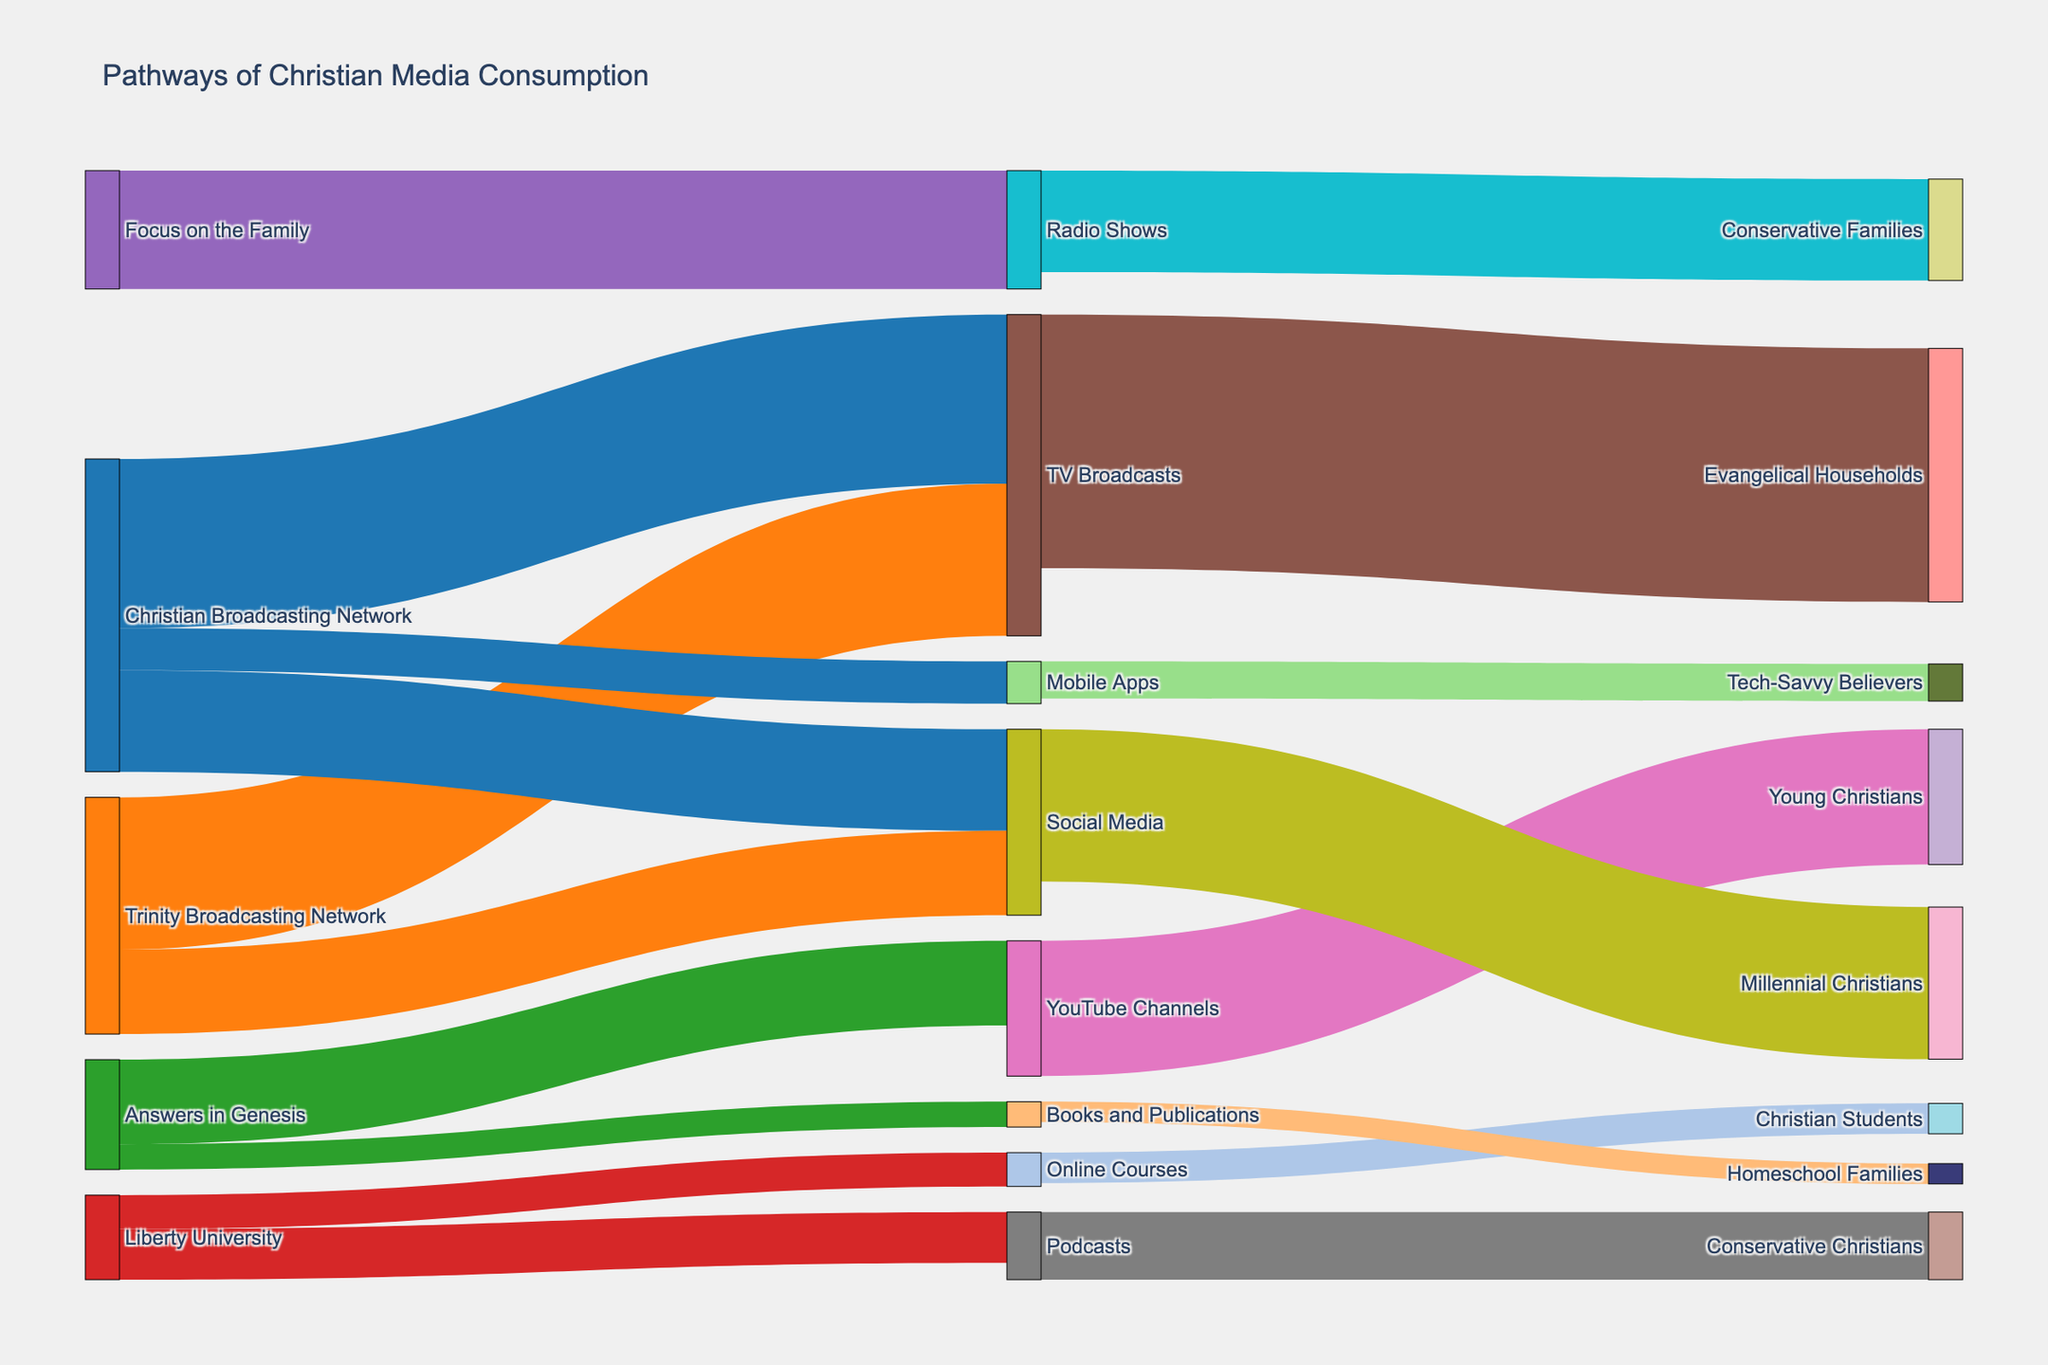What's the primary distribution channel for the Christian Broadcasting Network? The Sankey diagram shows that the Christian Broadcasting Network primarily distributes through TV Broadcasts, which has the highest path value of 1,000,000.
Answer: TV Broadcasts Which media format has the greatest total number of end users? Summing up the end user values for each media format: TV Broadcasts (1,500,000), YouTube Channels (800,000), Podcasts (400,000), Social Media (900,000), Radio Shows (600,000), Online Courses (180,000), and Mobile Apps (220,000). TV Broadcasts have the highest value.
Answer: TV Broadcasts How many end users do Homeschool Families receive content through Books and Publications? From the Sankey diagram, 120,000 Homeschool Families receive content via Books and Publications.
Answer: 120,000 Which content creator has the most diverse distribution channels? The Sankey diagram shows the number of different distribution channels each content creator uses: Christian Broadcasting Network (TV Broadcasts, Social Media, Mobile Apps), Trinity Broadcasting Network (TV Broadcasts, Social Media), Answers in Genesis (YouTube Channels, Books and Publications), Liberty University (Podcasts, Online Courses), Focus on the Family (Radio Shows). The Christian Broadcasting Network has the most diverse coverage with three channels.
Answer: Christian Broadcasting Network How many conservative families receive content from Radio Shows? According to the Sankey diagram, 600,000 Conservative Families receive content via Radio Shows.
Answer: 600,000 Which content creator connects to Conservative Christians through Podcasts? The Sankey diagram indicates that Liberty University distributes Podcasts to Conservative Christians.
Answer: Liberty University If the values representing Young Christians and Tech-Savvy Believers were combined, what would be their total? Young Christians have a value of 800,000 and Tech-Savvy Believers have a value of 220,000. Their combined total would be 800,000 + 220,000.
Answer: 1,020,000 Which media format connects most with Millennial Christians? The Sankey diagram shows that Social Media connects with Millennial Christians, with a value of 900,000.
Answer: Social Media 